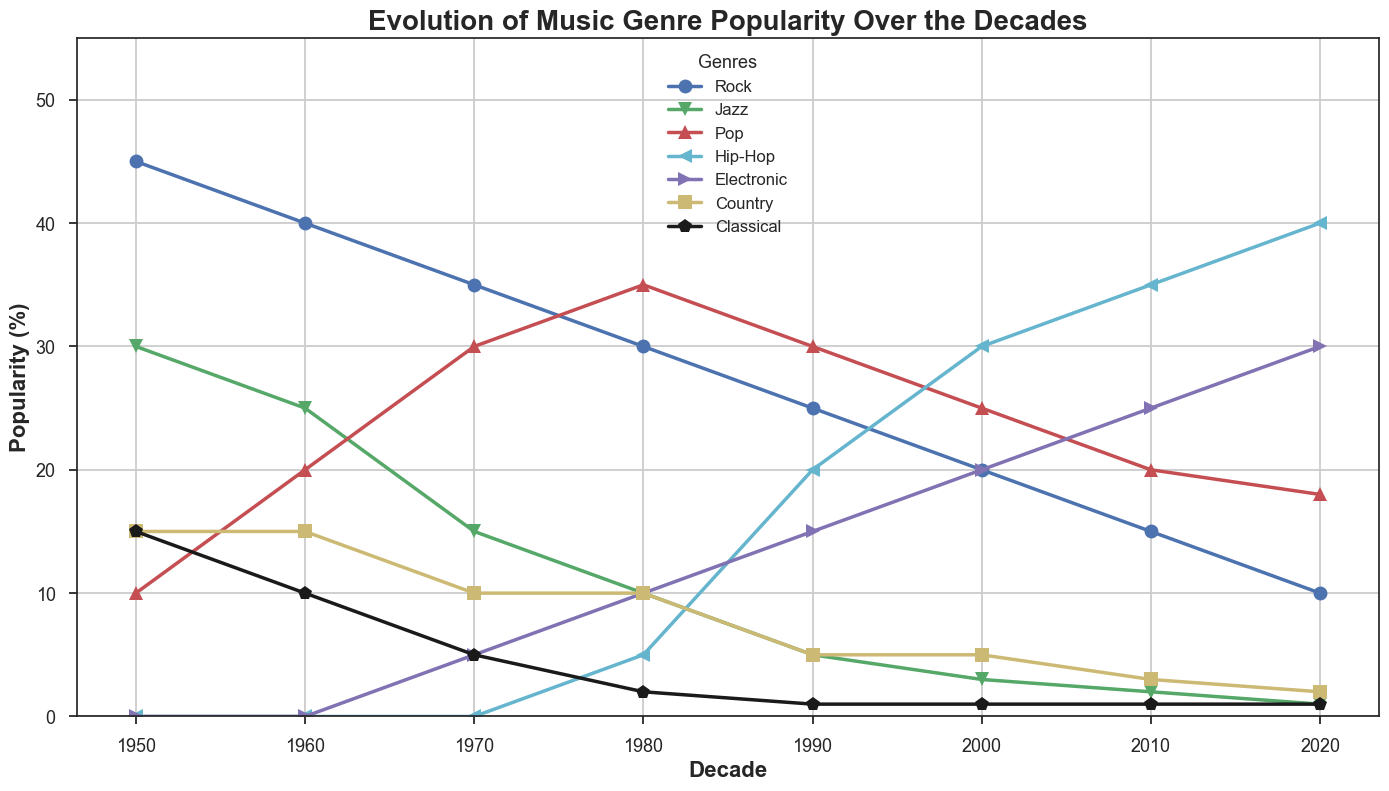What's the trend for the popularity of Rock music from the 1950s to the 2020s? Start in the 1950s at 45%, Rock's popularity declines steadily across the decades to 10% in the 2020s.
Answer: Declining trend Which decade saw the highest popularity in Hip-Hop music? Hip-Hop music gains its highest percentage in the 2020s with a peak of 40%.
Answer: 2020s How did the popularity of Jazz change between the 1960s and the 1980s? Jazz’s popularity diminishes from 25% in the 1960s to just 10% in the 1980s.
Answer: Decreased Compare the popularity of Electronic and Country music in the 2000s. Which was more popular? In the 2000s, Electronic music is at 20%, while Country music is at 5%. Electronic is more popular.
Answer: Electronic In which decade did Pop music first surpass Rock in popularity? From the 1970s where Rock (35%) gave way to Pop (30%), Pop first surpasses Rock in the 1980s with 35% compared to Rock's 30%.
Answer: 1980s Calculate the average popularity of Classical music over the decades. Sum the popularity of Classical music for all decades: 15+10+5+2+1+1+1+1 = 36. Divide by the number of decades: 36/8 = 4.5%
Answer: 4.5% What's the combined popularity of Hip-Hop and Electronic music in the 2010s? In the 2010s, Hip-Hop is at 35% and Electronic is at 25%. Sum them up: 35 + 25 = 60%
Answer: 60% Which genre declined the most from its peak to the 2020s? Rock music peaked at 45% in the 1950s and declined to 10% in the 2020s, a decrease of 35%.
Answer: Rock What decade did Pop music see its peak in popularity? Pop music peaks in the 1980s at 35%.
Answer: 1980s How does the popularity of Country music in the 1950s compare to the popularity of Classical music in the same period? In the 1950s, Country music and Classical music both stand at 15%.
Answer: Equal 